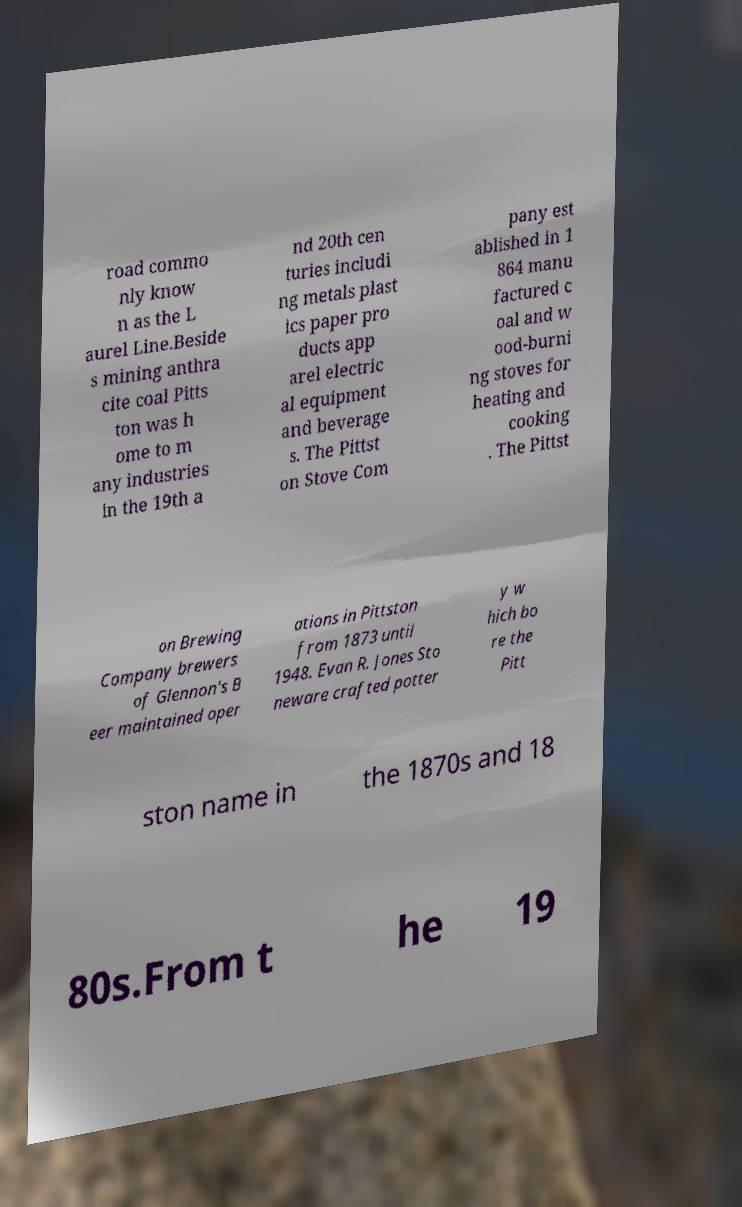I need the written content from this picture converted into text. Can you do that? road commo nly know n as the L aurel Line.Beside s mining anthra cite coal Pitts ton was h ome to m any industries in the 19th a nd 20th cen turies includi ng metals plast ics paper pro ducts app arel electric al equipment and beverage s. The Pittst on Stove Com pany est ablished in 1 864 manu factured c oal and w ood-burni ng stoves for heating and cooking . The Pittst on Brewing Company brewers of Glennon's B eer maintained oper ations in Pittston from 1873 until 1948. Evan R. Jones Sto neware crafted potter y w hich bo re the Pitt ston name in the 1870s and 18 80s.From t he 19 